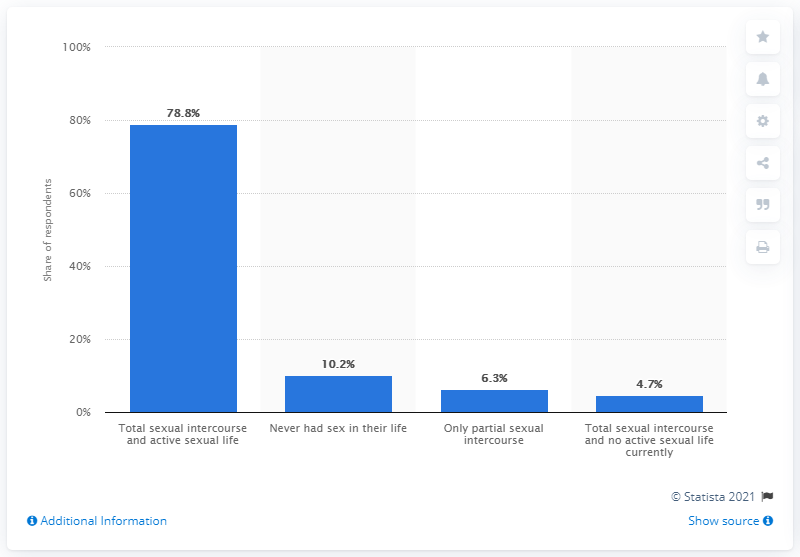Specify some key components in this picture. In Italy, a survey found that 78.8% of young adults reported having had total sexual intercourse and leading an active sexual life. 